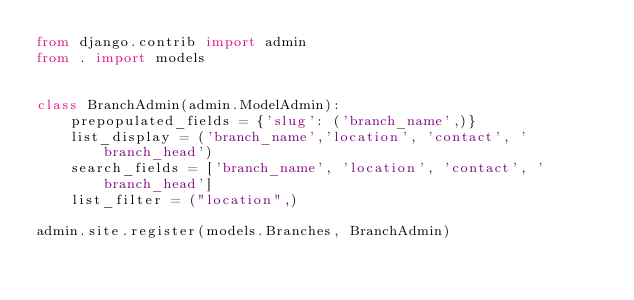<code> <loc_0><loc_0><loc_500><loc_500><_Python_>from django.contrib import admin
from . import models


class BranchAdmin(admin.ModelAdmin):
    prepopulated_fields = {'slug': ('branch_name',)}
    list_display = ('branch_name','location', 'contact', 'branch_head')
    search_fields = ['branch_name', 'location', 'contact', 'branch_head']
    list_filter = ("location",)

admin.site.register(models.Branches, BranchAdmin)</code> 